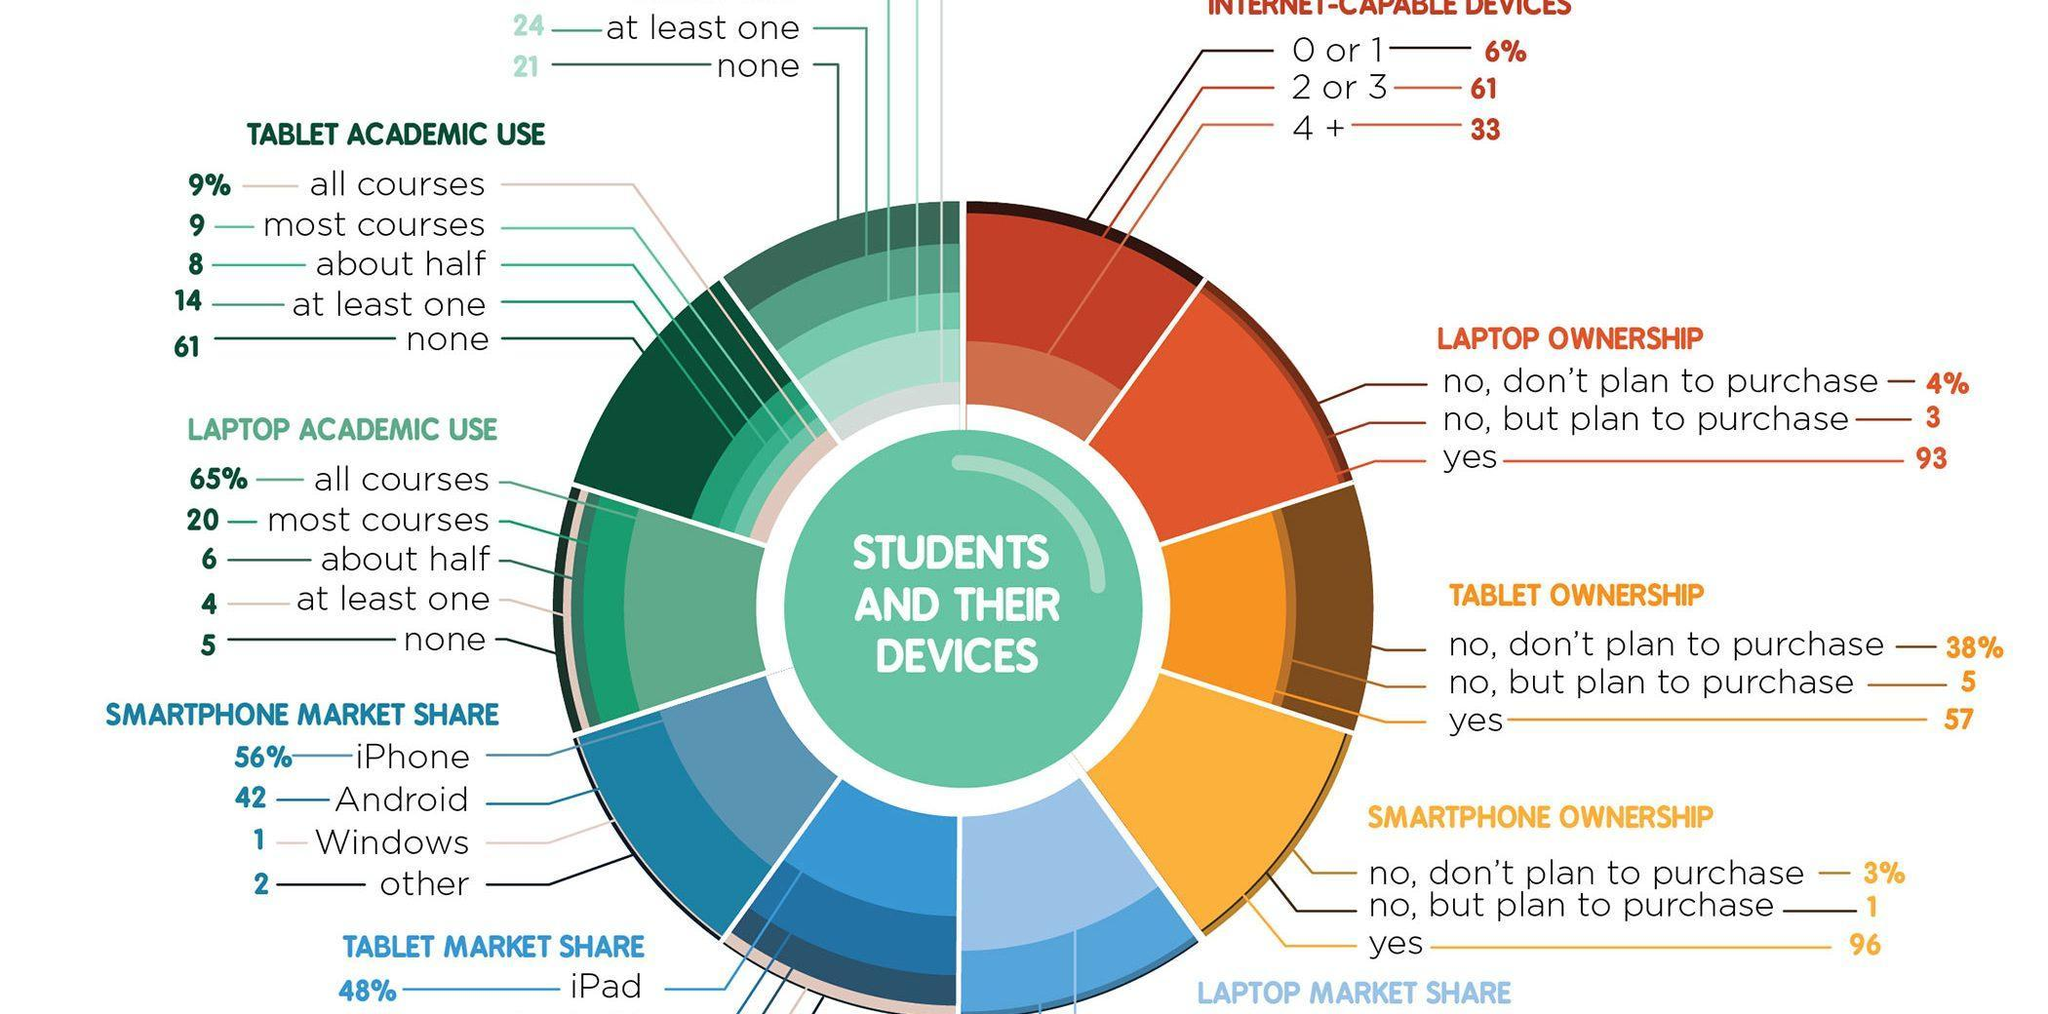What percent of students use tablet for all courses and most courses?
Answer the question with a short phrase. 18% Which is the most popular smartphone in the market? iPhone What percent of students will purchase laptop? 93% What percent of students will not purchase a smartphone? 3% 